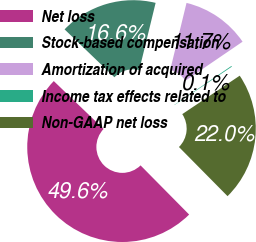Convert chart. <chart><loc_0><loc_0><loc_500><loc_500><pie_chart><fcel>Net loss<fcel>Stock-based compensation<fcel>Amortization of acquired<fcel>Income tax effects related to<fcel>Non-GAAP net loss<nl><fcel>49.59%<fcel>16.62%<fcel>11.67%<fcel>0.14%<fcel>21.98%<nl></chart> 